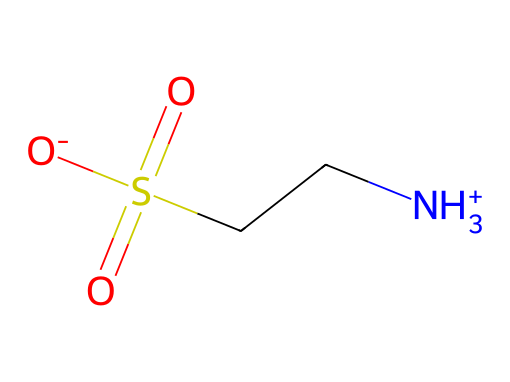What is the name of this chemical? The chemical structure corresponds to taurine, which is indicated by the overall arrangement of atoms in the SMILES representation.
Answer: taurine How many sulfur atoms are in this molecule? The SMILES notation shows one sulfur atom (S) in the structure, indicating that there is only one sulfur atom present in taurine.
Answer: 1 What type of functional group is present in taurine? The structure contains a sulfonic acid functional group characterized by the -S(=O)(O-) portion in the chemical formula.
Answer: sulfonic acid Is taurine a polar molecule? The presence of the amino group (-NH3+) and sulfonic acid suggests strong dipole interactions, which are characteristic of polar molecules.
Answer: yes What is the main characteristic that classifies taurine as a non-electrolyte? Taurine does not dissociate into ions when dissolved in solution, maintaining its molecular form without contributing to conductivity which is typical for electrolytes.
Answer: does not dissociate What does the positive charge in the structure indicate about taurine's behavior in solution? The positively charged amino group suggests that taurine can interact favorably with water, enhancing its solubility in aqueous solutions.
Answer: enhances solubility What is the total count of oxygen atoms in this molecule? Analyzing the SMILES notation, there are three oxygen atoms present, indicated by the three -O portions surrounding the sulfur atom.
Answer: 3 